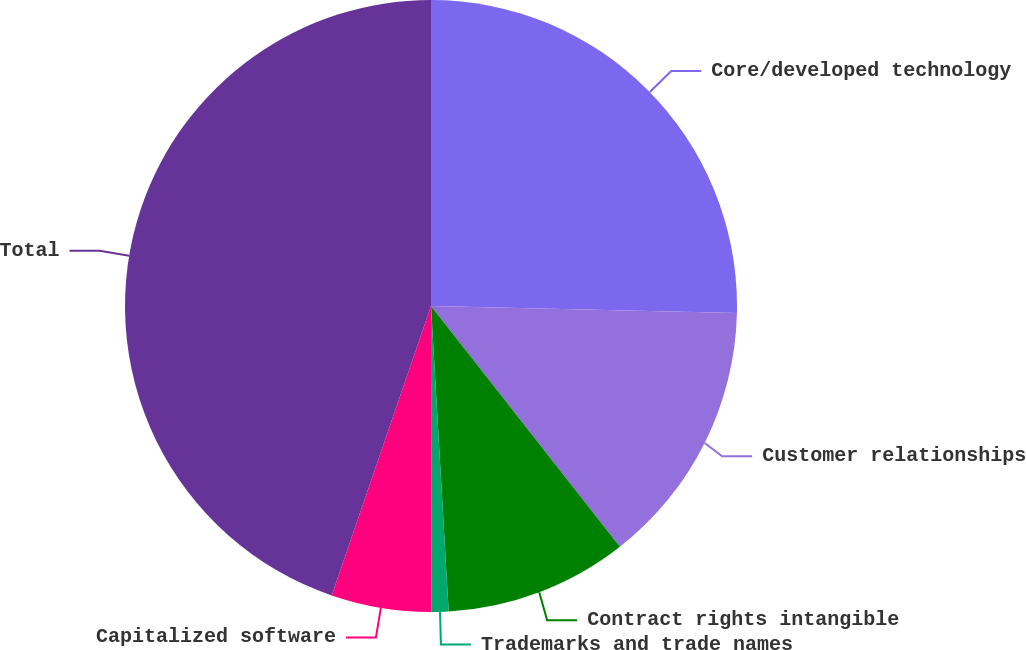<chart> <loc_0><loc_0><loc_500><loc_500><pie_chart><fcel>Core/developed technology<fcel>Customer relationships<fcel>Contract rights intangible<fcel>Trademarks and trade names<fcel>Capitalized software<fcel>Total<nl><fcel>25.36%<fcel>14.05%<fcel>9.67%<fcel>0.9%<fcel>5.28%<fcel>44.74%<nl></chart> 